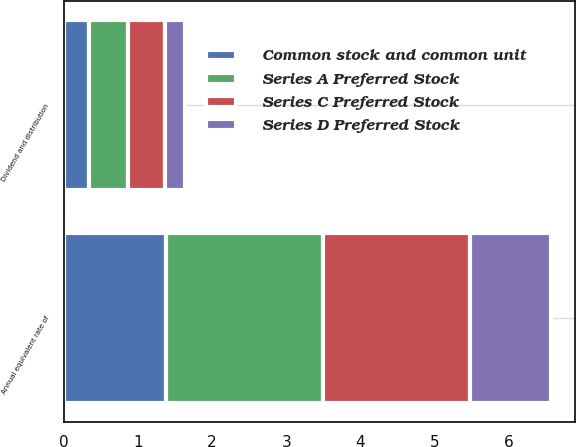<chart> <loc_0><loc_0><loc_500><loc_500><stacked_bar_chart><ecel><fcel>Dividend and distribution<fcel>Annual equivalent rate of<nl><fcel>Series A Preferred Stock<fcel>0.53<fcel>2.12<nl><fcel>Series C Preferred Stock<fcel>0.49<fcel>1.97<nl><fcel>Series D Preferred Stock<fcel>0.27<fcel>1.09<nl><fcel>Common stock and common unit<fcel>0.34<fcel>1.38<nl></chart> 